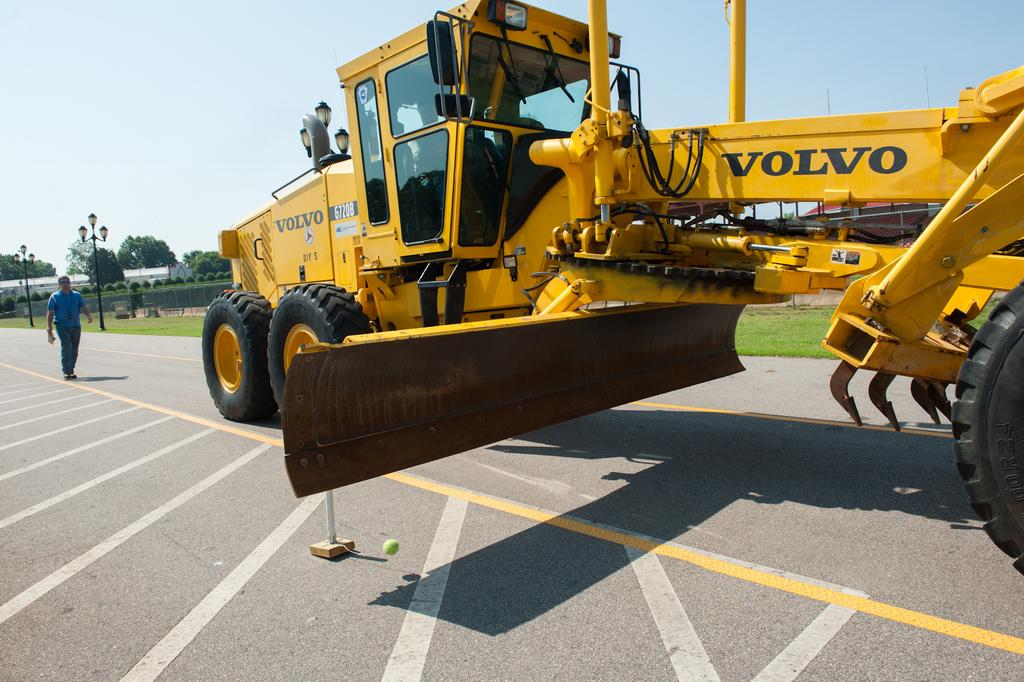<image>
Present a compact description of the photo's key features. Volvo heavy machinery with a warning label and Diy five logo. 